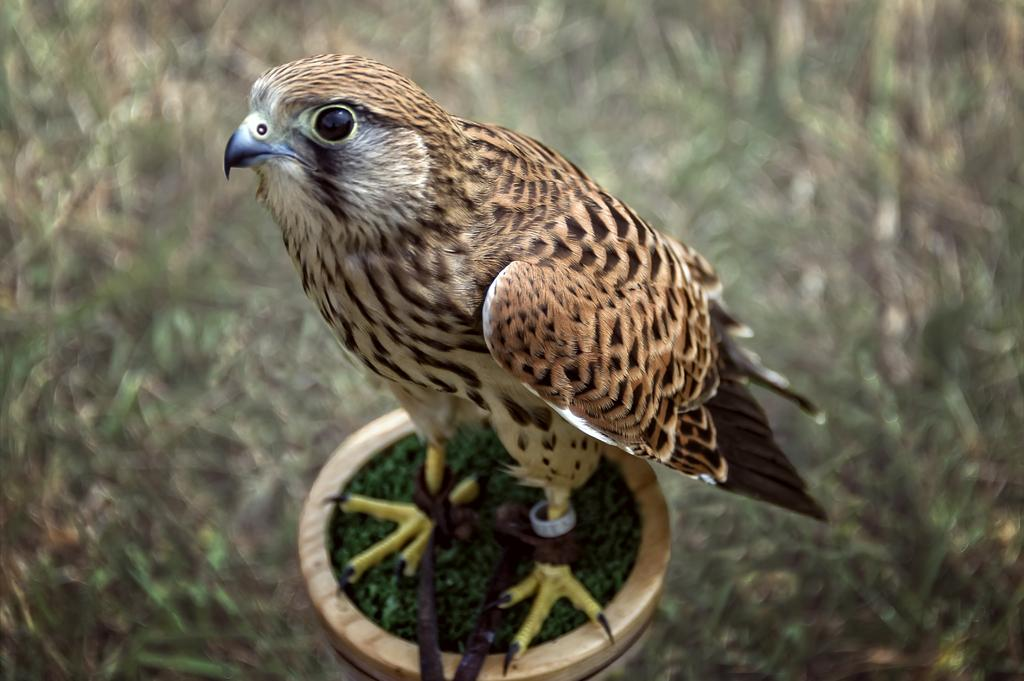What type of animal is present in the image? There is a bird in the image. What object can be seen alongside the bird? There is a pot in the image. Can you describe the background of the image? The background of the image is blurred. What type of news can be heard coming from the bird in the image? There is no indication in the image that the bird is making any sounds or delivering news. What type of branch is the bird perched on in the image? There is no branch present in the image; the bird is not perched on anything. 